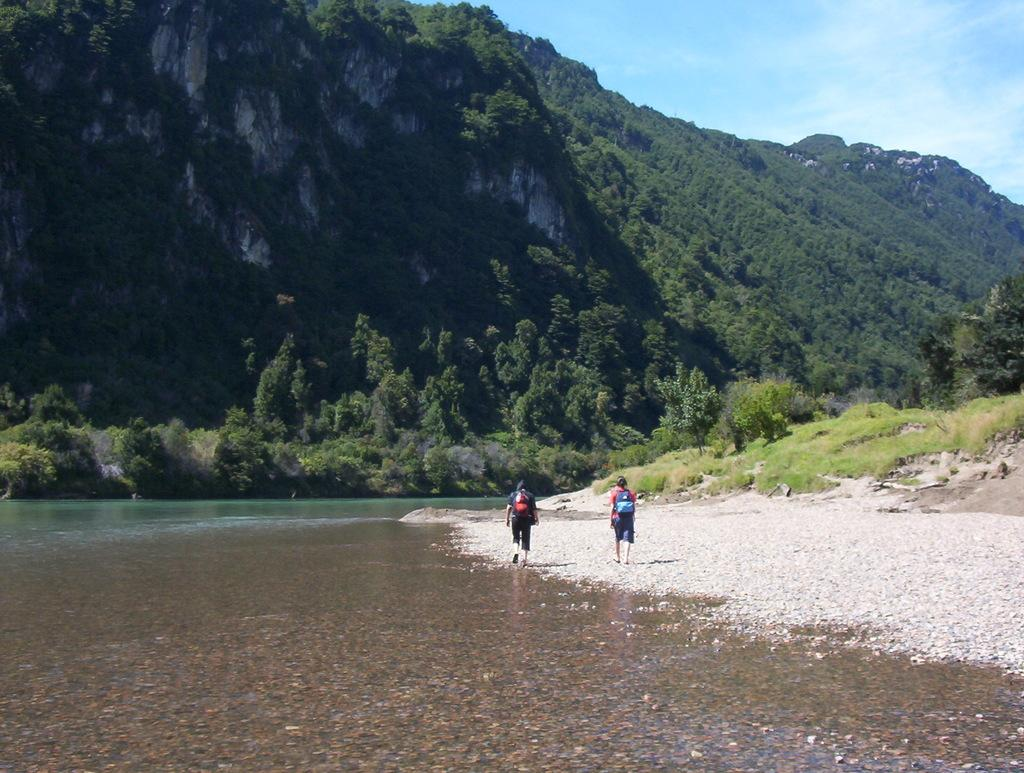How many people are walking in the image? There are two persons walking in the image. What is visible in the background of the image? There is water and trees visible in the image. What is visible at the top of the image? The sky is visible at the top of the image. Who is the owner of the tramp in the image? There is no tramp present in the image. Is there a sidewalk visible in the image? The provided facts do not mention a sidewalk, so we cannot determine if one is visible in the image. 